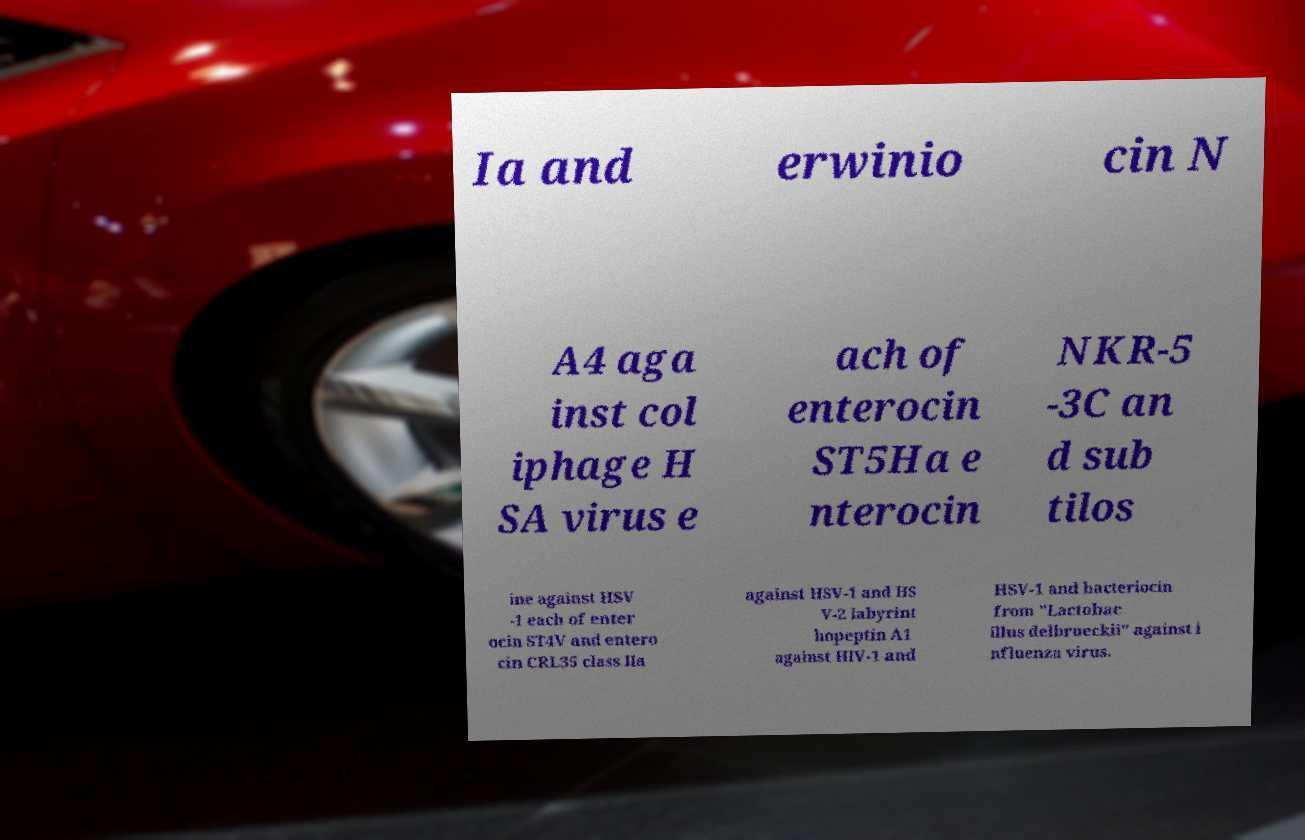Please identify and transcribe the text found in this image. Ia and erwinio cin N A4 aga inst col iphage H SA virus e ach of enterocin ST5Ha e nterocin NKR-5 -3C an d sub tilos ine against HSV -1 each of enter ocin ST4V and entero cin CRL35 class IIa against HSV-1 and HS V-2 labyrint hopeptin A1 against HIV-1 and HSV-1 and bacteriocin from "Lactobac illus delbrueckii" against i nfluenza virus. 